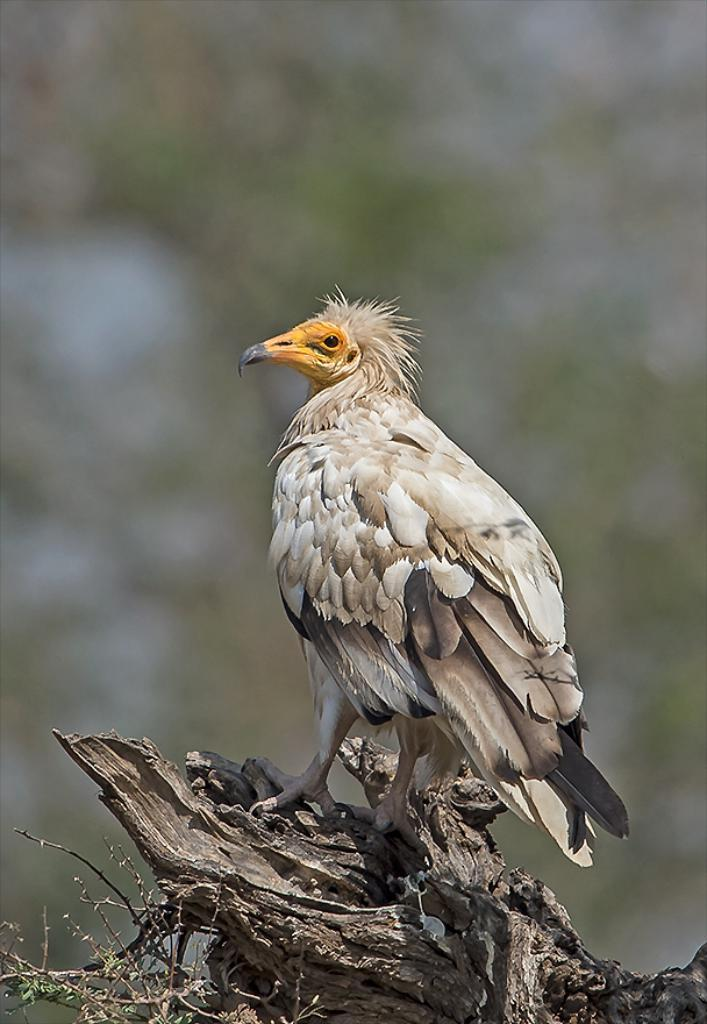What type of animal can be seen in the image? There is a bird in the image. What is the bird standing on? The bird is standing on a wooden branch. What type of experience does the bird have in the image? The image does not provide any information about the bird's experience, so it cannot be determined from the picture. 